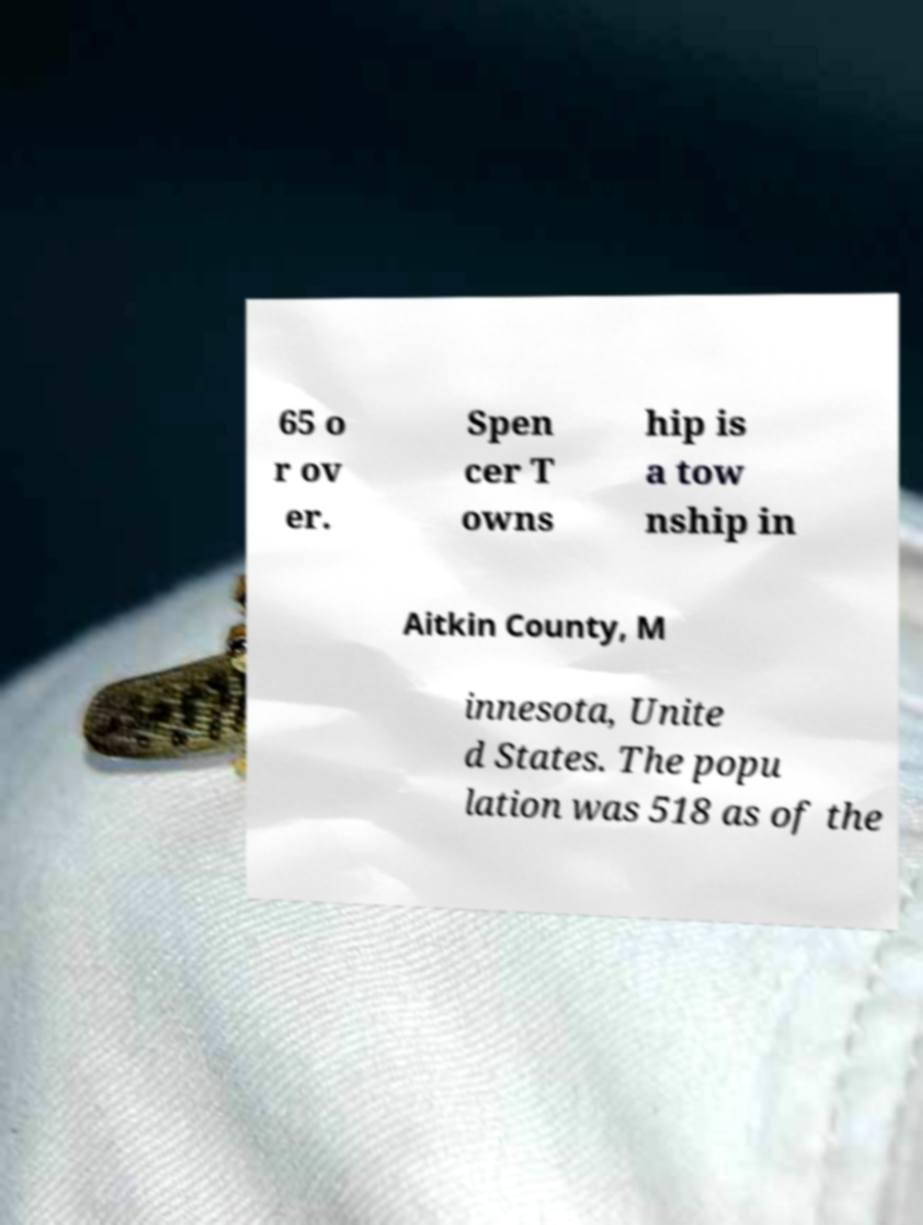Can you read and provide the text displayed in the image?This photo seems to have some interesting text. Can you extract and type it out for me? 65 o r ov er. Spen cer T owns hip is a tow nship in Aitkin County, M innesota, Unite d States. The popu lation was 518 as of the 